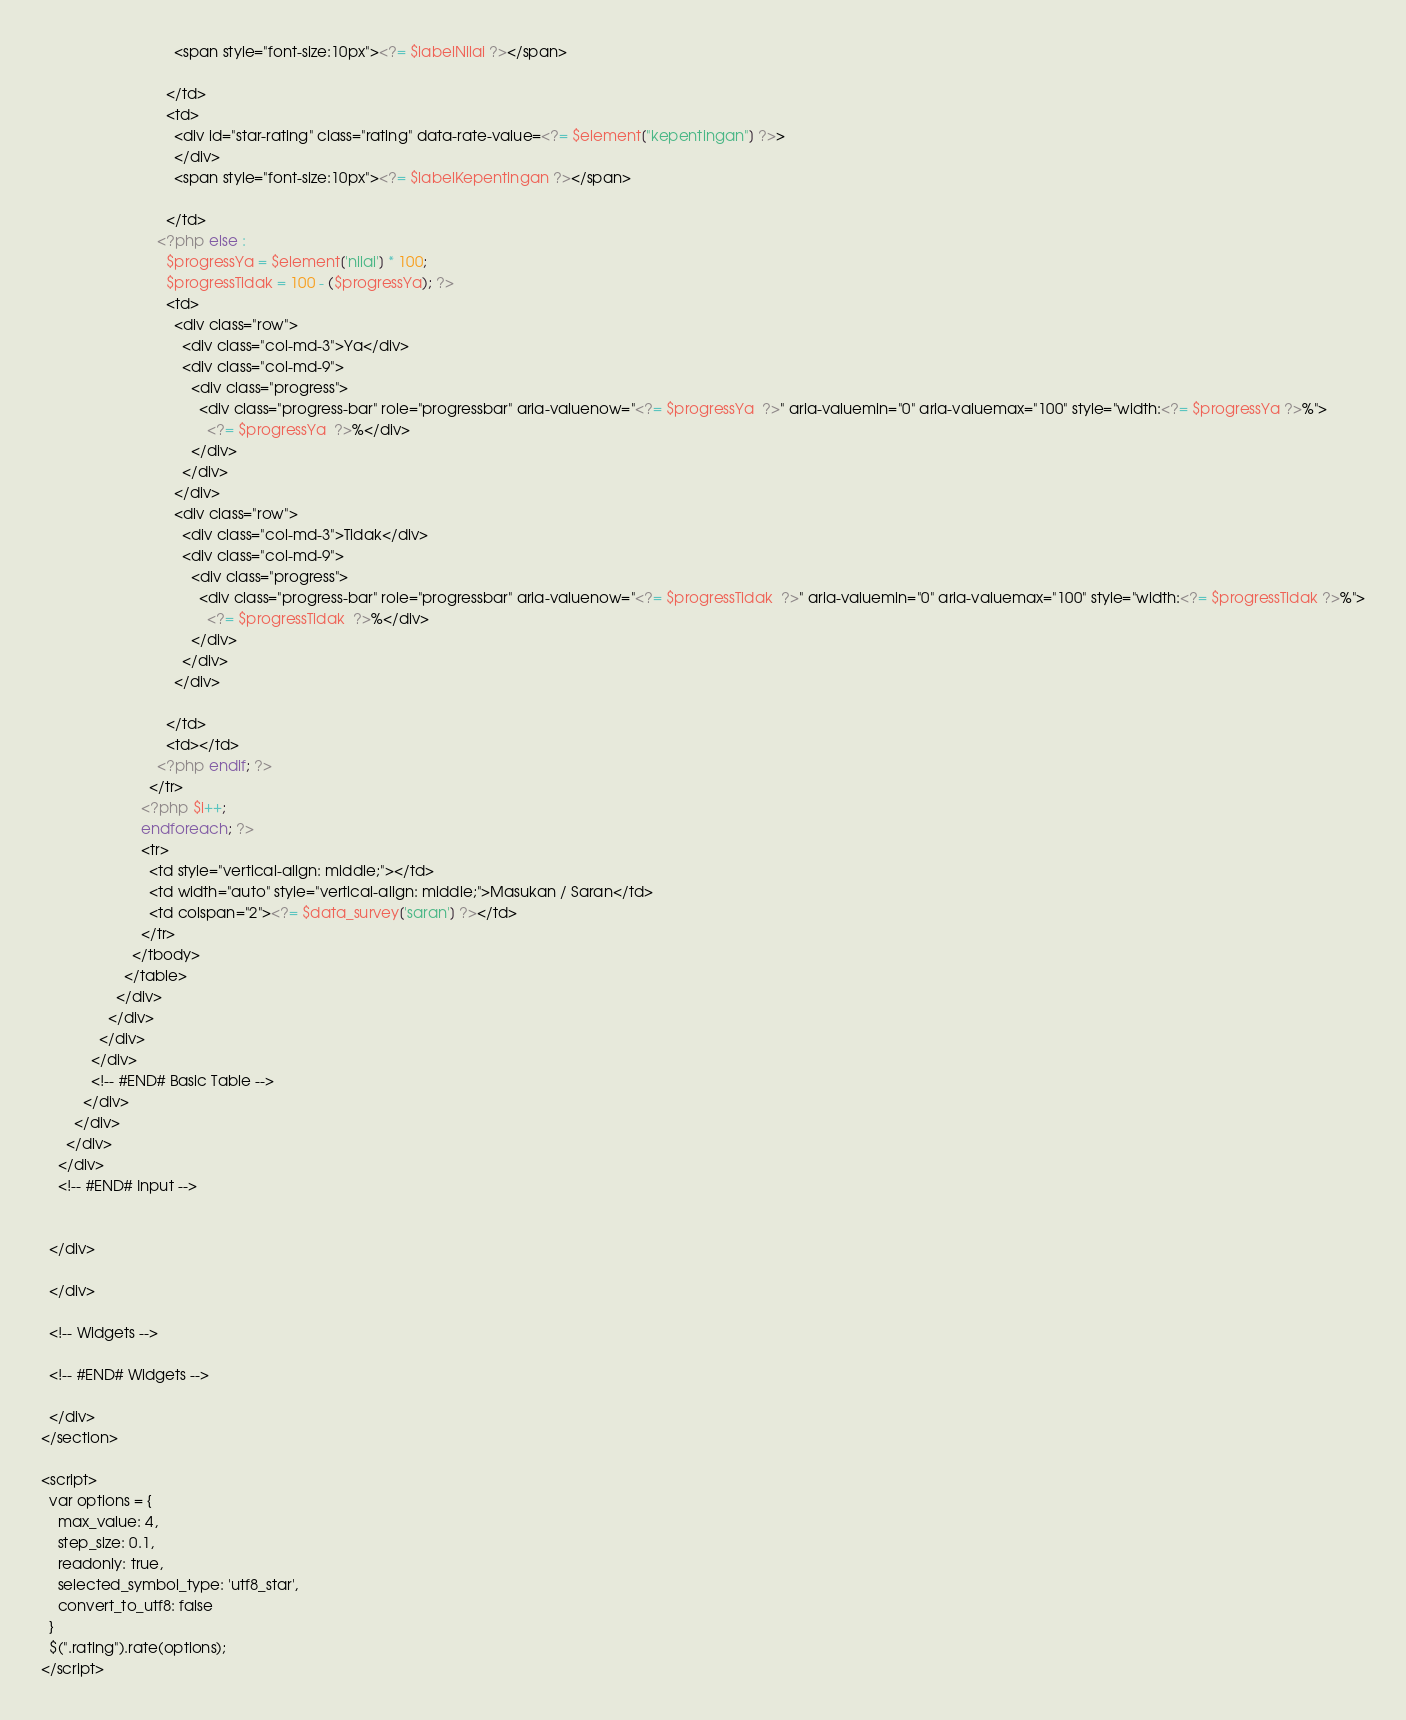<code> <loc_0><loc_0><loc_500><loc_500><_PHP_>                                <span style="font-size:10px"><?= $labelNilai ?></span>

                              </td>
                              <td>
                                <div id="star-rating" class="rating" data-rate-value=<?= $element["kepentingan"] ?>>
                                </div>
                                <span style="font-size:10px"><?= $labelKepentingan ?></span>

                              </td>
                            <?php else :
                              $progressYa = $element['nilai'] * 100;
                              $progressTidak = 100 - ($progressYa); ?>
                              <td>
                                <div class="row">
                                  <div class="col-md-3">Ya</div>
                                  <div class="col-md-9">
                                    <div class="progress">
                                      <div class="progress-bar" role="progressbar" aria-valuenow="<?= $progressYa  ?>" aria-valuemin="0" aria-valuemax="100" style="width:<?= $progressYa ?>%">
                                        <?= $progressYa  ?>%</div>
                                    </div>
                                  </div>
                                </div>
                                <div class="row">
                                  <div class="col-md-3">Tidak</div>
                                  <div class="col-md-9">
                                    <div class="progress">
                                      <div class="progress-bar" role="progressbar" aria-valuenow="<?= $progressTidak  ?>" aria-valuemin="0" aria-valuemax="100" style="width:<?= $progressTidak ?>%">
                                        <?= $progressTidak  ?>%</div>
                                    </div>
                                  </div>
                                </div>

                              </td>
                              <td></td>
                            <?php endif; ?>
                          </tr>
                        <?php $i++;
                        endforeach; ?>
                        <tr>
                          <td style="vertical-align: middle;"></td>
                          <td width="auto" style="vertical-align: middle;">Masukan / Saran</td>
                          <td colspan="2"><?= $data_survey['saran'] ?></td>
                        </tr>
                      </tbody>
                    </table>
                  </div>
                </div>
              </div>
            </div>
            <!-- #END# Basic Table -->
          </div>
        </div>
      </div>
    </div>
    <!-- #END# Input -->


  </div>

  </div>

  <!-- Widgets -->

  <!-- #END# Widgets -->

  </div>
</section>

<script>
  var options = {
    max_value: 4,
    step_size: 0.1,
    readonly: true,
    selected_symbol_type: 'utf8_star',
    convert_to_utf8: false
  }
  $(".rating").rate(options);
</script></code> 